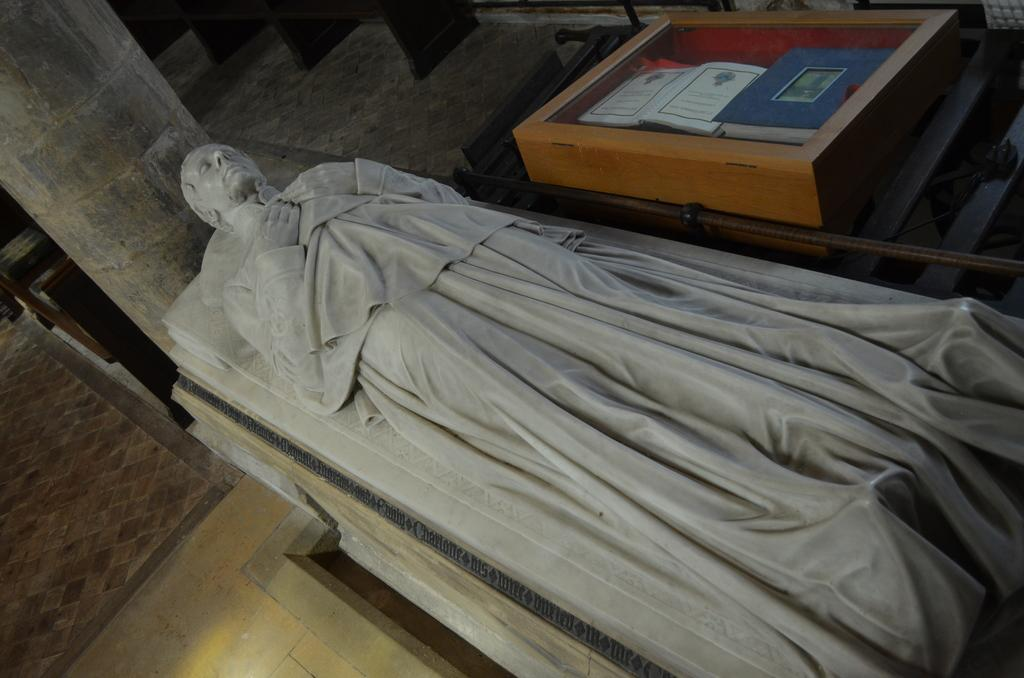What is the main subject of the image? There is a statue of a person in the image. What other architectural feature can be seen in the image? There is a pillar in the image. What type of objects are stored in a box in the image? There are books in a box in the image. Can you describe any other objects present in the image? Yes, there are other objects present in the image, but their specific details are not mentioned in the provided facts. How many legs does the statue have in the image? The provided facts do not mention the number of legs on the statue, so it cannot be determined from the image. 